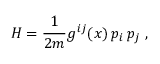Convert formula to latex. <formula><loc_0><loc_0><loc_500><loc_500>H = \frac { 1 } { 2 m } g ^ { i j } ( x ) \, p _ { i } \, p _ { j } \, ,</formula> 